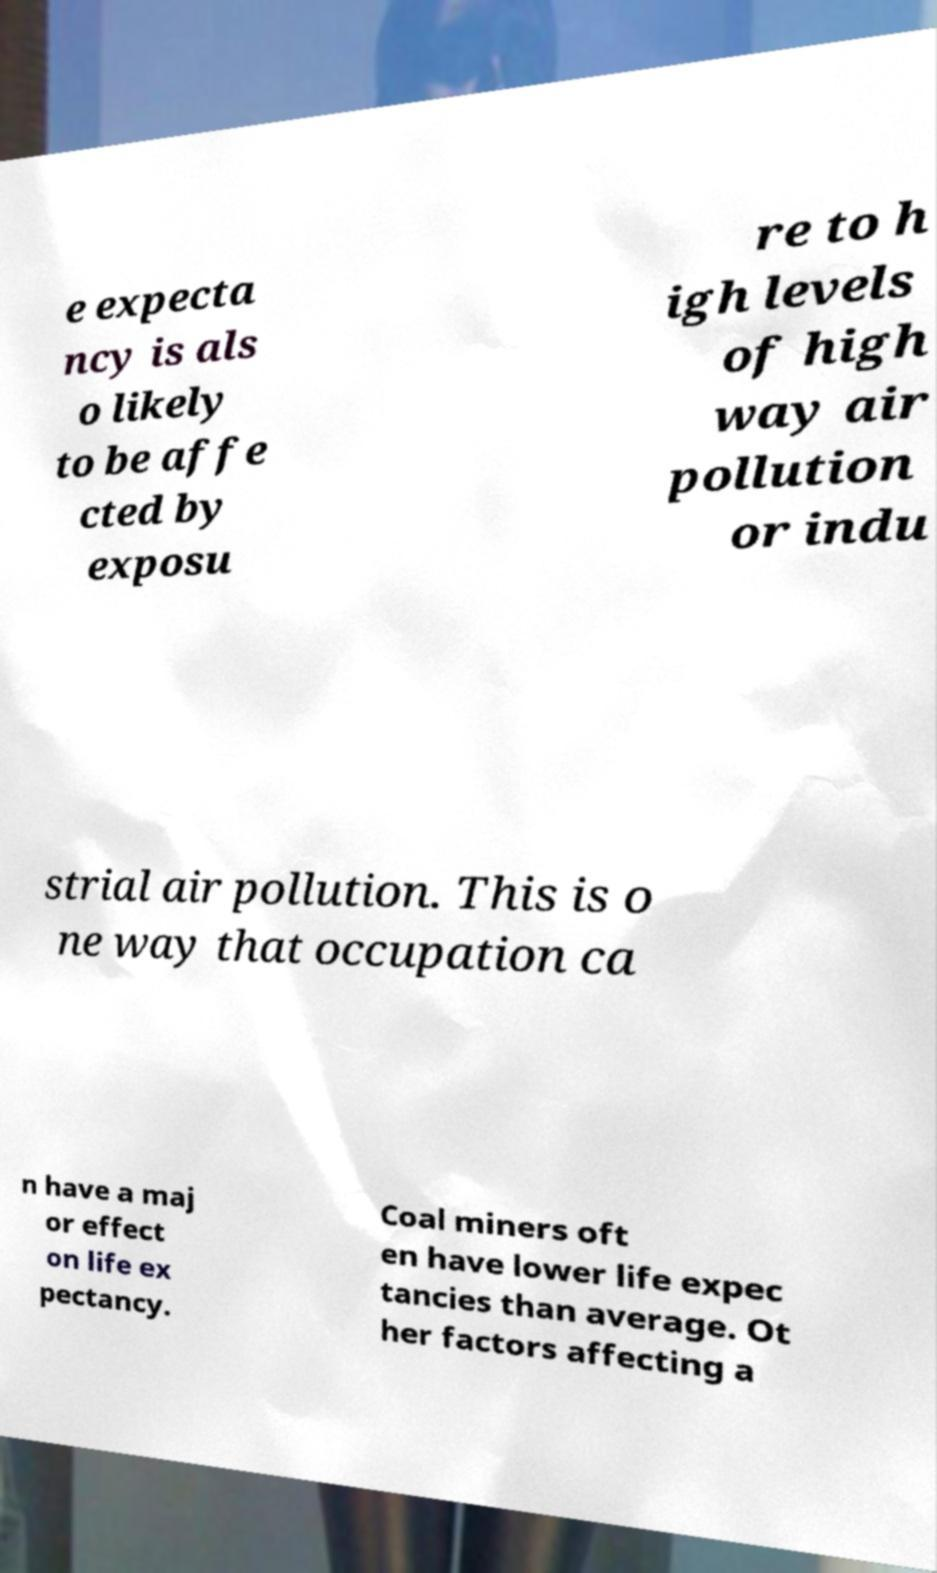Could you extract and type out the text from this image? e expecta ncy is als o likely to be affe cted by exposu re to h igh levels of high way air pollution or indu strial air pollution. This is o ne way that occupation ca n have a maj or effect on life ex pectancy. Coal miners oft en have lower life expec tancies than average. Ot her factors affecting a 